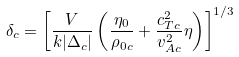<formula> <loc_0><loc_0><loc_500><loc_500>\delta _ { c } = \left [ \frac { V } { k | \Delta _ { c } | } \left ( \frac { \eta _ { 0 } } { \rho _ { 0 c } } + \frac { c _ { T c } ^ { 2 } } { v _ { A c } ^ { 2 } } \eta \right ) \right ] ^ { 1 / 3 }</formula> 